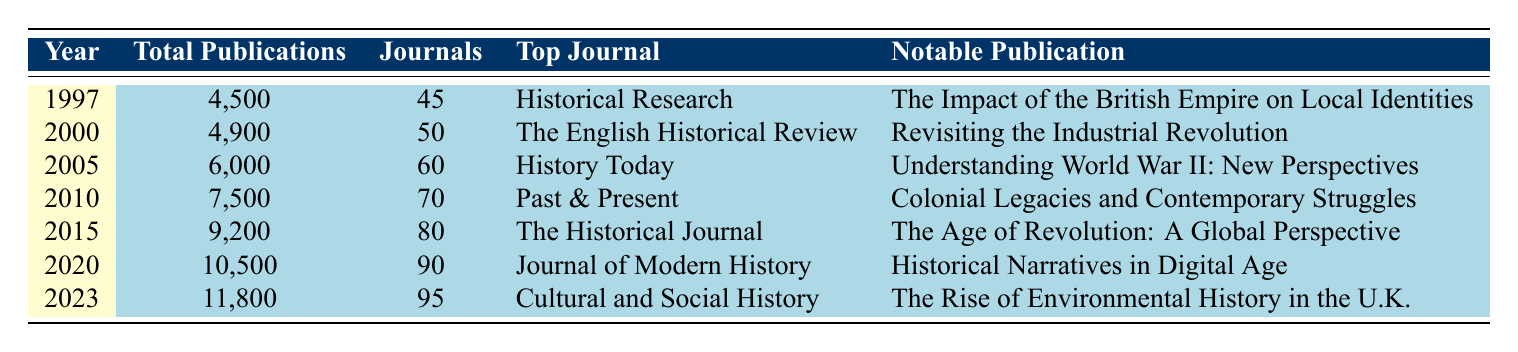What was the total number of historical research publications in 2010? The table indicates that in 2010, the total number of historical research publications was listed directly in the second column as 7,500.
Answer: 7,500 Which journal had the highest number of publications in 2015? In 2015, the top journal listed in the table is "The Historical Journal," shown in the fourth column.
Answer: The Historical Journal What is the increase in total publications from 2000 to 2020? To find the increase, subtract the total publications in 2000 (4,900) from the total publications in 2020 (10,500): 10,500 - 4,900 = 5,600.
Answer: 5,600 Did the number of journals increase every five years from 1997 to 2023? By checking each year, the number of journals increased from 45 in 1997 to 95 in 2023 without any decreases. Thus, the statement is true.
Answer: Yes What is the average number of publications per year from 1997 to 2023? To calculate the average, first sum the total publications from each year: (4,500 + 4,900 + 6,000 + 7,500 + 9,200 + 10,500 + 11,800) = 54,400. Then divide this sum by the number of years (7): 54,400 / 7 = 7,771.43.
Answer: 7,771.43 Which noteworthy publication was associated with the year 2023? From the table, the notable publication for the year 2023 is listed as "The Rise of Environmental History in the U.K." in the fifth column.
Answer: The Rise of Environmental History in the U.K Was the number of total publications greater in 2020 than the total number of journals in 2015? In 2020, total publications were 10,500, while in 2015, the number of journals was 80. Therefore, 10,500 is greater than 80, making the statement true.
Answer: Yes What was the percentage increase in total publications from 2010 to 2015? First, calculate the difference between total publications in 2015 (9,200) and 2010 (7,500): 9,200 - 7,500 = 1,700. Next, divide the difference by the 2010 figure: 1,700 / 7,500 = 0.2267. Finally, multiply by 100 for the percentage: 0.2267 * 100 = 22.67%.
Answer: 22.67% 